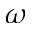Convert formula to latex. <formula><loc_0><loc_0><loc_500><loc_500>\omega</formula> 